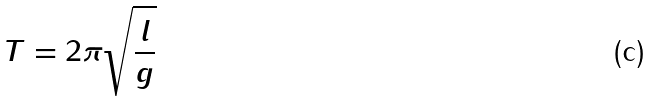<formula> <loc_0><loc_0><loc_500><loc_500>T = 2 \pi \sqrt { \frac { l } { g } }</formula> 